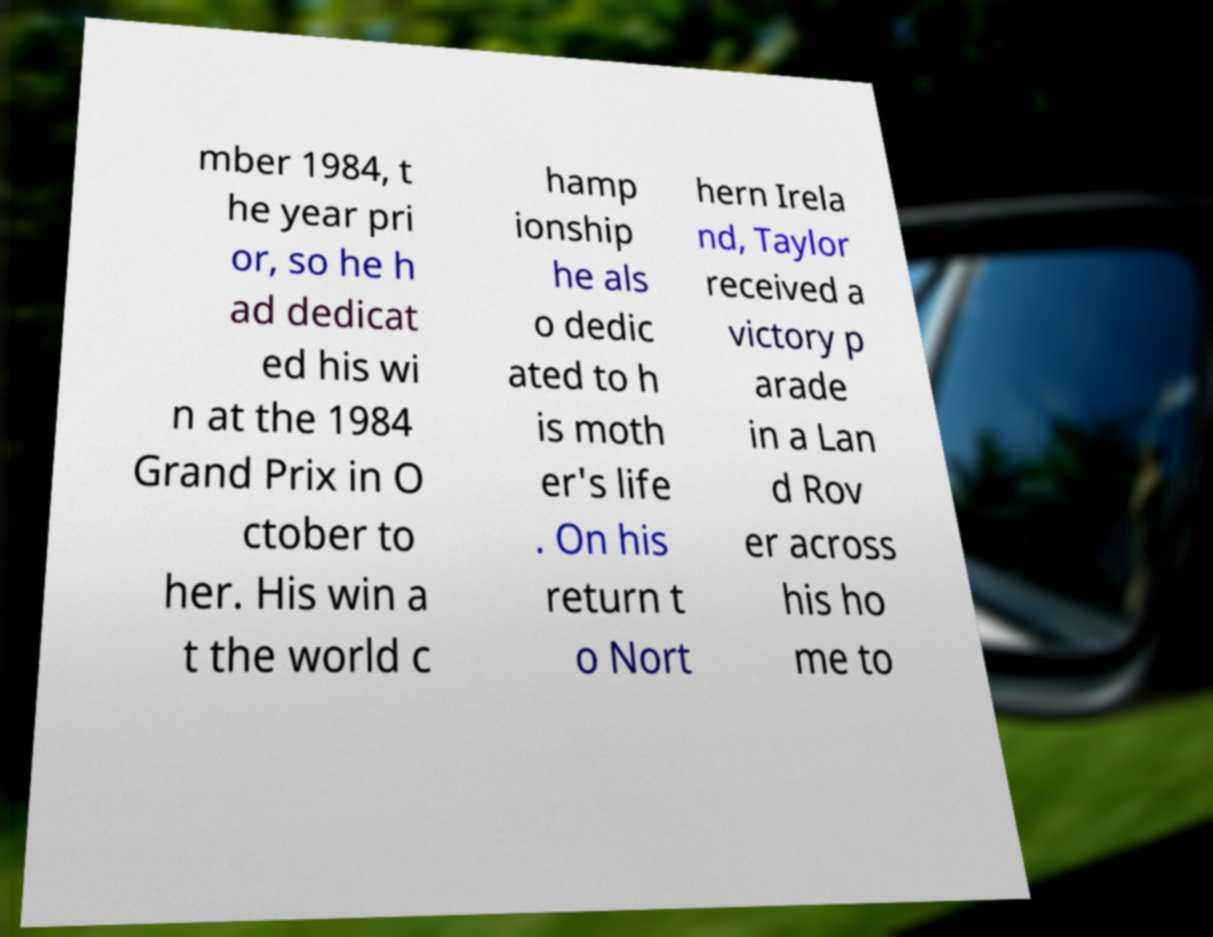Could you extract and type out the text from this image? mber 1984, t he year pri or, so he h ad dedicat ed his wi n at the 1984 Grand Prix in O ctober to her. His win a t the world c hamp ionship he als o dedic ated to h is moth er's life . On his return t o Nort hern Irela nd, Taylor received a victory p arade in a Lan d Rov er across his ho me to 